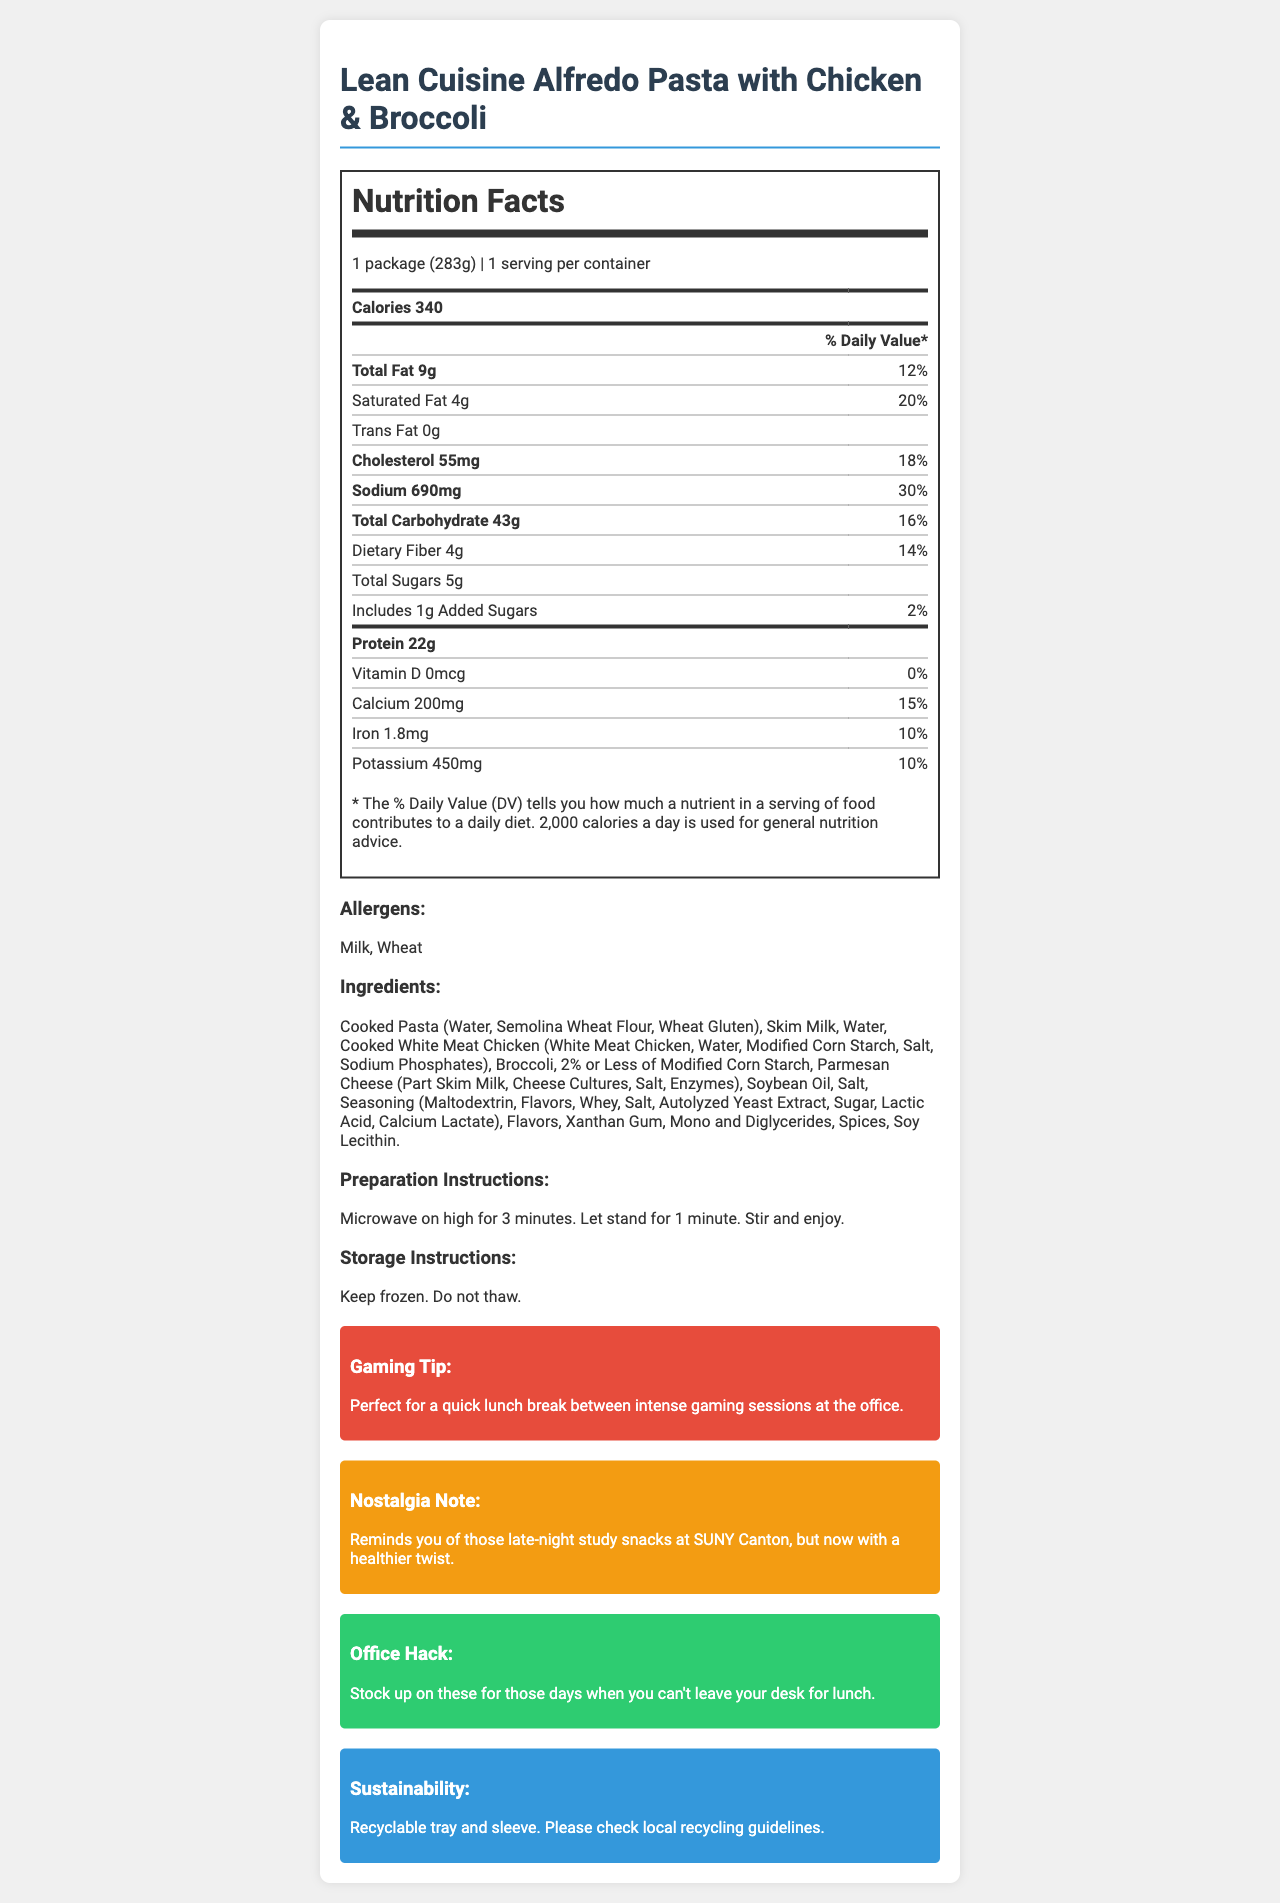what is the serving size of the Lean Cuisine Alfredo Pasta with Chicken & Broccoli? The document states that the serving size of the product is "1 package (283g)".
Answer: 1 package (283g) how many calories are in one serving of this product? The document mentions that there are 340 calories in one serving of the Lean Cuisine Alfredo Pasta with Chicken & Broccoli.
Answer: 340 how much sodium does the product contain? The document lists the sodium content as 690 mg, which is 30% of the daily value.
Answer: 690 mg what allergens are present in the product? The allergens section of the document states that the product contains milk and wheat.
Answer: Milk, Wheat what is the preparation instruction for this product? The preparation instructions are provided in the document and state this exact method for preparing the product.
Answer: Microwave on high for 3 minutes. Let stand for 1 minute. Stir and enjoy. which nutrient has the highest % daily value in the product? The % daily value for sodium is the highest at 30%, which is higher than the other nutrients listed in the document.
Answer: Sodium at 30% which two nutrients have the same daily value percentage? A. Fiber and Iron B. Calcium and Potassium C. Total Sugars and Vitamin D D. Total Fat and Saturated Fat Both calcium and potassium have a daily value percentage of 10%, according to the document.
Answer: B. Calcium and Potassium which of the following oils is included in the ingredients list? A. Olive oil B. Soybean oil C. Canola oil The ingredients section lists soybean oil as one of the ingredients.
Answer: B. Soybean oil does the product contain any trans fat? The document states that the trans fat content is 0 grams.
Answer: No is this product suitable for someone with a gluten allergy? The product contains wheat, which is a source of gluten, making it unsuitable for someone with a gluten allergy.
Answer: No summarize the main content of the nutrition facts label for this product. The summary synthesizes information about the product’s nutritional content, preparation, allergens, and additional convenience and sustainability notes contained in the document.
Answer: The Lean Cuisine Alfredo Pasta with Chicken & Broccoli provides detailed nutritional information for a quick, microwaveable lunch option that is ideal for office settings. It has 340 calories, with significant contributions to daily values from sodium (30%), saturated fat (20%), and total fat (12%). It contains milk and wheat allergens and requires just a few minutes in the microwave to prepare. The recyclable tray and sleeve make it a sustainable choice. Additional notes highlight its convenience for gamers, nostalgia for former students, and practicality for office workers. how many different types of fats are listed on the nutrition label? The document lists total fat, saturated fat, and trans fat, making for three different types of fats.
Answer: Three what is the percentage of daily value for dietary fiber? The document indicates that the dietary fiber has a daily value percentage of 14%.
Answer: 14% how many grams of protein are in a serving of this product? A. 20g B. 22g C. 25g D. 30g The document lists the protein content as 22g per serving.
Answer: B. 22g does the document provide any cooking tips for other microwaveable foods? The document only provides preparation instructions specifically for the Lean Cuisine Alfredo Pasta with Chicken & Broccoli and does not include general cooking tips for other microwaveable foods.
Answer: Not enough information is this product dairy-free? This product is not dairy-free as it contains skim milk and Parmesan cheese made from part skim milk.
Answer: No 